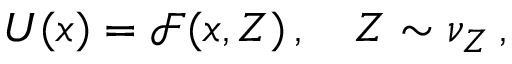Convert formula to latex. <formula><loc_0><loc_0><loc_500><loc_500>U ( x ) = \mathcal { F } ( x , Z ) \, , \quad Z \sim \nu _ { Z } \, ,</formula> 